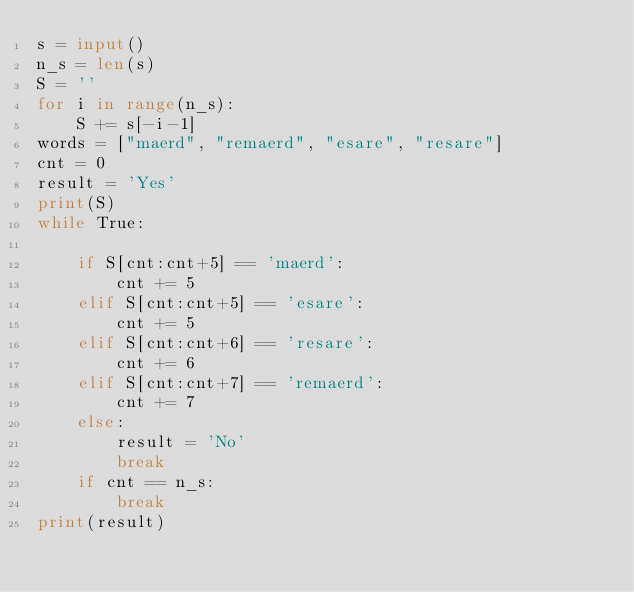Convert code to text. <code><loc_0><loc_0><loc_500><loc_500><_Python_>s = input()
n_s = len(s)
S = ''
for i in range(n_s):
    S += s[-i-1]
words = ["maerd", "remaerd", "esare", "resare"]
cnt = 0
result = 'Yes'
print(S)
while True:
    
    if S[cnt:cnt+5] == 'maerd':
        cnt += 5
    elif S[cnt:cnt+5] == 'esare':
        cnt += 5
    elif S[cnt:cnt+6] == 'resare':
        cnt += 6
    elif S[cnt:cnt+7] == 'remaerd':
        cnt += 7
    else:
        result = 'No'
        break
    if cnt == n_s:
        break
print(result)</code> 